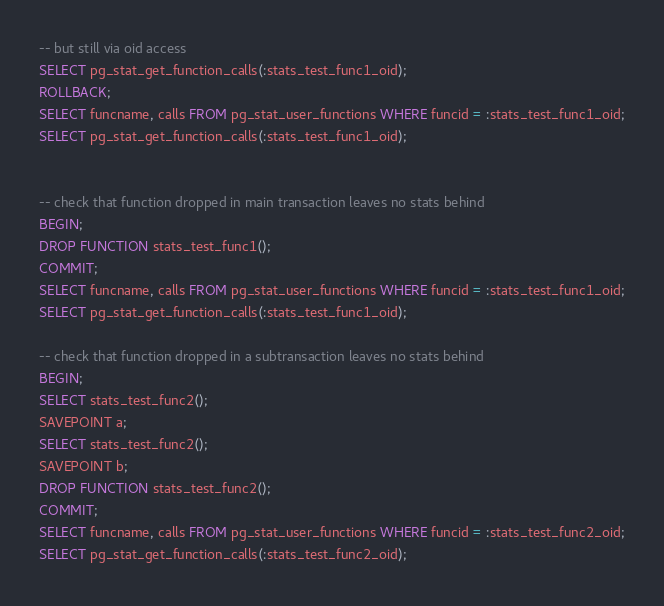Convert code to text. <code><loc_0><loc_0><loc_500><loc_500><_SQL_>-- but still via oid access
SELECT pg_stat_get_function_calls(:stats_test_func1_oid);
ROLLBACK;
SELECT funcname, calls FROM pg_stat_user_functions WHERE funcid = :stats_test_func1_oid;
SELECT pg_stat_get_function_calls(:stats_test_func1_oid);


-- check that function dropped in main transaction leaves no stats behind
BEGIN;
DROP FUNCTION stats_test_func1();
COMMIT;
SELECT funcname, calls FROM pg_stat_user_functions WHERE funcid = :stats_test_func1_oid;
SELECT pg_stat_get_function_calls(:stats_test_func1_oid);

-- check that function dropped in a subtransaction leaves no stats behind
BEGIN;
SELECT stats_test_func2();
SAVEPOINT a;
SELECT stats_test_func2();
SAVEPOINT b;
DROP FUNCTION stats_test_func2();
COMMIT;
SELECT funcname, calls FROM pg_stat_user_functions WHERE funcid = :stats_test_func2_oid;
SELECT pg_stat_get_function_calls(:stats_test_func2_oid);

</code> 